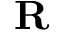Convert formula to latex. <formula><loc_0><loc_0><loc_500><loc_500>{ R }</formula> 